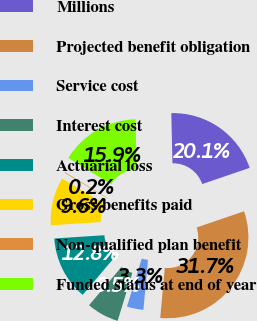Convert chart to OTSL. <chart><loc_0><loc_0><loc_500><loc_500><pie_chart><fcel>Millions<fcel>Projected benefit obligation<fcel>Service cost<fcel>Interest cost<fcel>Actuarial loss<fcel>Gross benefits paid<fcel>Non-qualified plan benefit<fcel>Funded status at end of year<nl><fcel>20.13%<fcel>31.68%<fcel>3.3%<fcel>6.46%<fcel>12.76%<fcel>9.61%<fcel>0.15%<fcel>15.91%<nl></chart> 